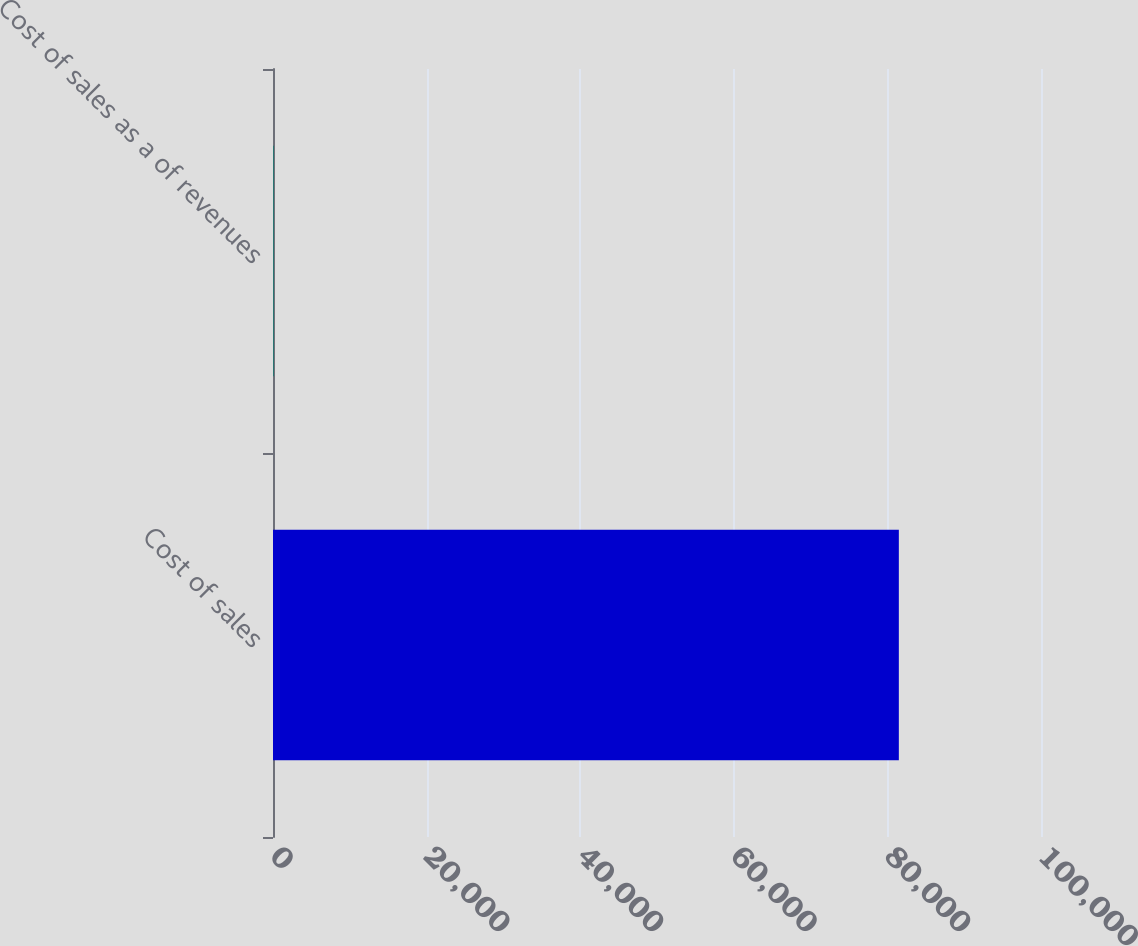<chart> <loc_0><loc_0><loc_500><loc_500><bar_chart><fcel>Cost of sales<fcel>Cost of sales as a of revenues<nl><fcel>81490<fcel>80.6<nl></chart> 